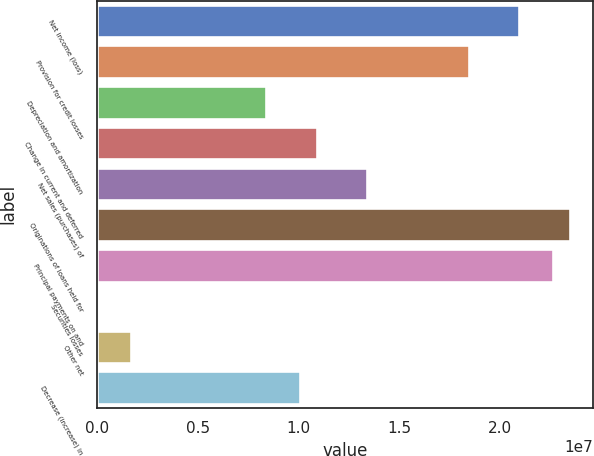Convert chart. <chart><loc_0><loc_0><loc_500><loc_500><bar_chart><fcel>Net income (loss)<fcel>Provision for credit losses<fcel>Depreciation and amortization<fcel>Change in current and deferred<fcel>Net sales (purchases) of<fcel>Originations of loans held for<fcel>Principal payments on and<fcel>Securities losses<fcel>Other net<fcel>Decrease (increase) in<nl><fcel>2.09502e+07<fcel>1.84374e+07<fcel>8.38622e+06<fcel>1.0899e+07<fcel>1.34118e+07<fcel>2.3463e+07<fcel>2.26254e+07<fcel>10249<fcel>1.68544e+06<fcel>1.00614e+07<nl></chart> 